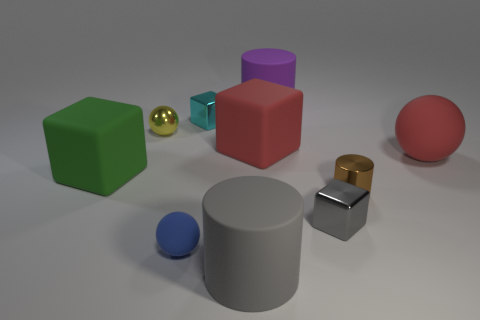Subtract all cyan cylinders. Subtract all purple spheres. How many cylinders are left? 3 Subtract all purple spheres. How many cyan cylinders are left? 0 Add 8 tiny cyans. How many large grays exist? 0 Subtract all brown rubber things. Subtract all blue objects. How many objects are left? 9 Add 2 yellow things. How many yellow things are left? 3 Add 2 small yellow cylinders. How many small yellow cylinders exist? 2 Subtract all red spheres. How many spheres are left? 2 Subtract all small cylinders. How many cylinders are left? 2 Subtract 1 purple cylinders. How many objects are left? 9 Subtract all cubes. How many objects are left? 6 